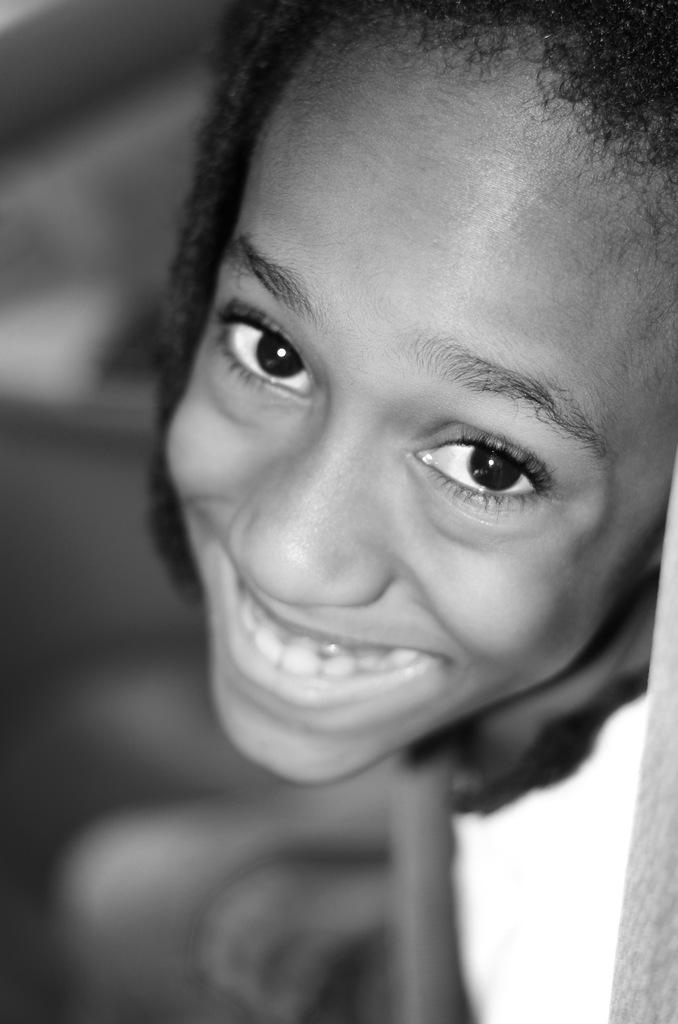What is the color scheme of the image? The image is black and white. Can you describe the person in the image? There is a person in the image, and they are smiling. What can be said about the background of the image? The background of the image is blurry. How many pipes can be seen in the image? There are no pipes present in the image. What is the existence of snakes in the image? There are no snakes present in the image. 